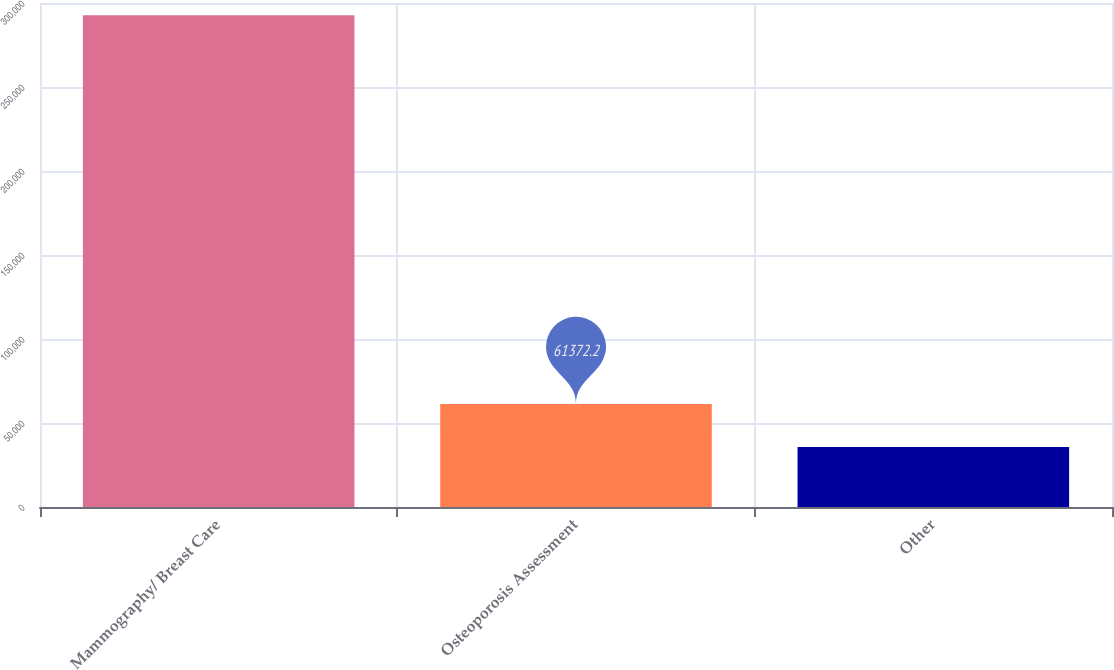<chart> <loc_0><loc_0><loc_500><loc_500><bar_chart><fcel>Mammography/ Breast Care<fcel>Osteoporosis Assessment<fcel>Other<nl><fcel>292773<fcel>61372.2<fcel>35661<nl></chart> 